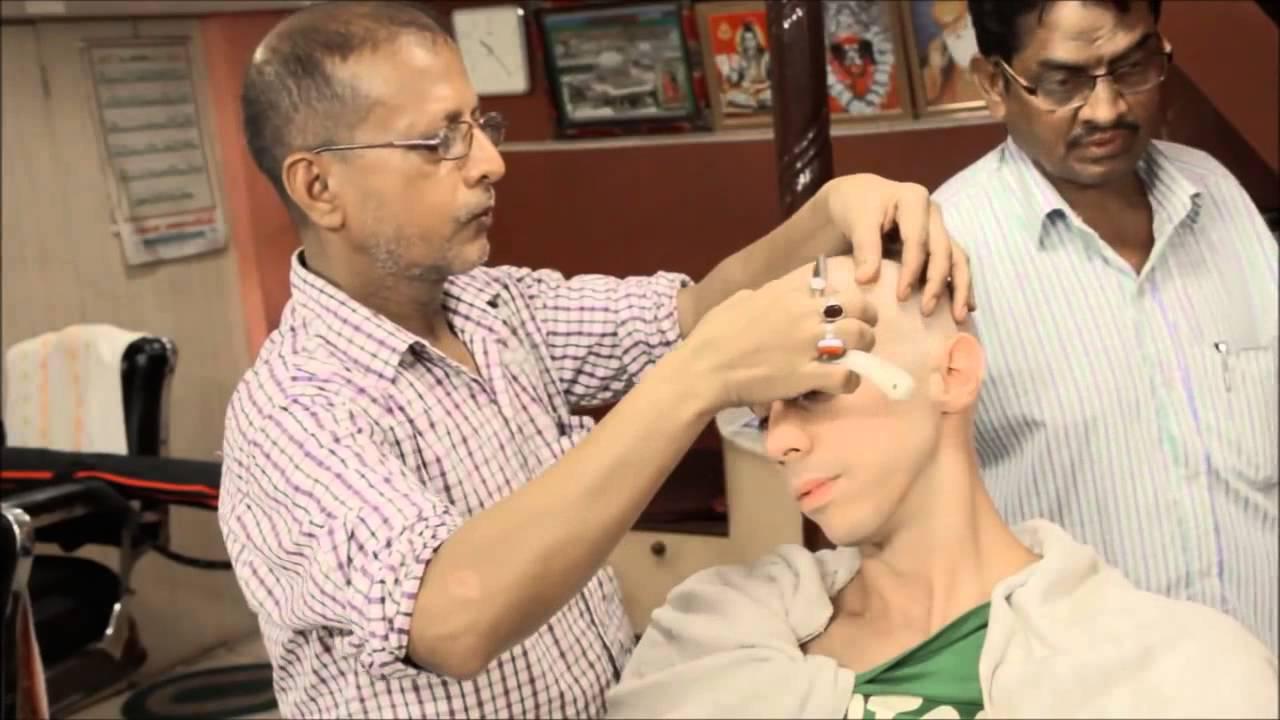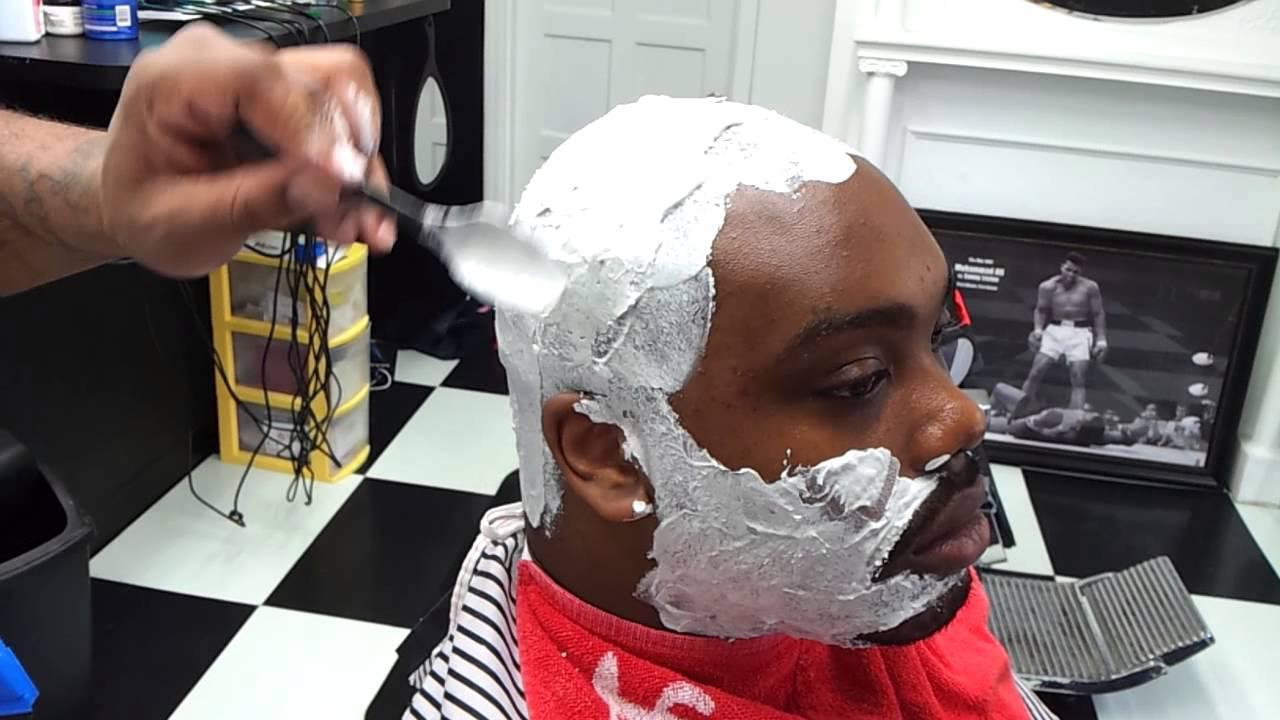The first image is the image on the left, the second image is the image on the right. Evaluate the accuracy of this statement regarding the images: "An image shows a woman with light blonde hair behind an adult male customer.". Is it true? Answer yes or no. No. The first image is the image on the left, the second image is the image on the right. Examine the images to the left and right. Is the description "The person in the image on the right is covered with a black smock" accurate? Answer yes or no. No. 